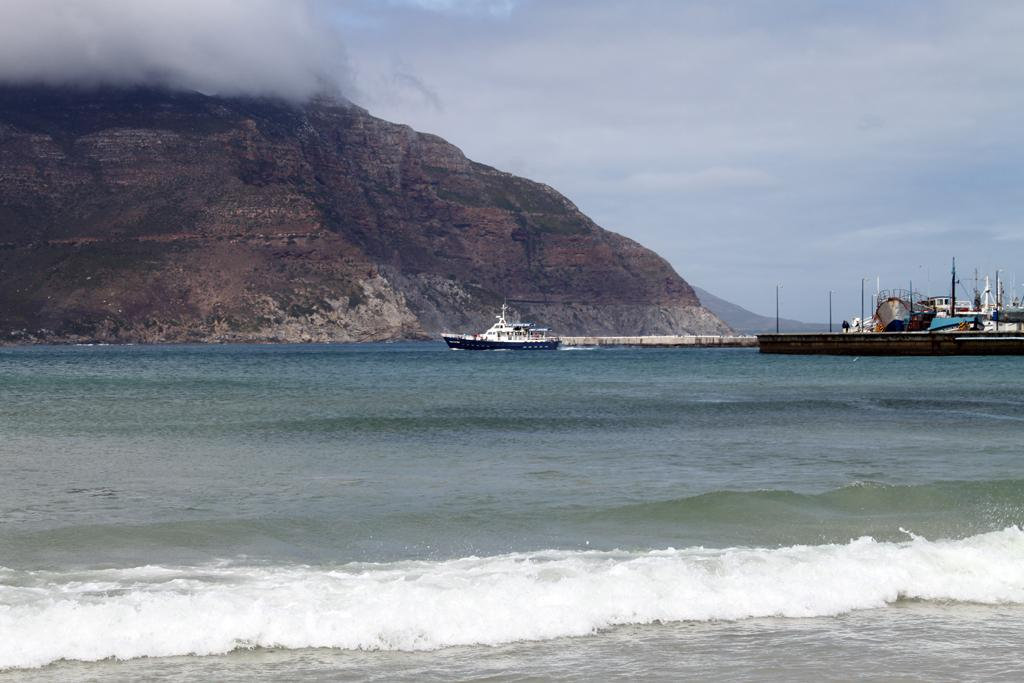What is the main subject of the image? The main subject of the image is ships. What type of environment can be seen in the image? There is water visible in the image, which suggests a maritime environment. What structures are present in the image? There are poles in the image. What is visible in the background of the image? The sky and hills are visible in the background of the image. How does the ship breathe in the image? Ships do not breathe; the question is not applicable to the image. What is the fifth element visible in the image? There are only four elements visible in the image: ships, water, sky, and hills. 